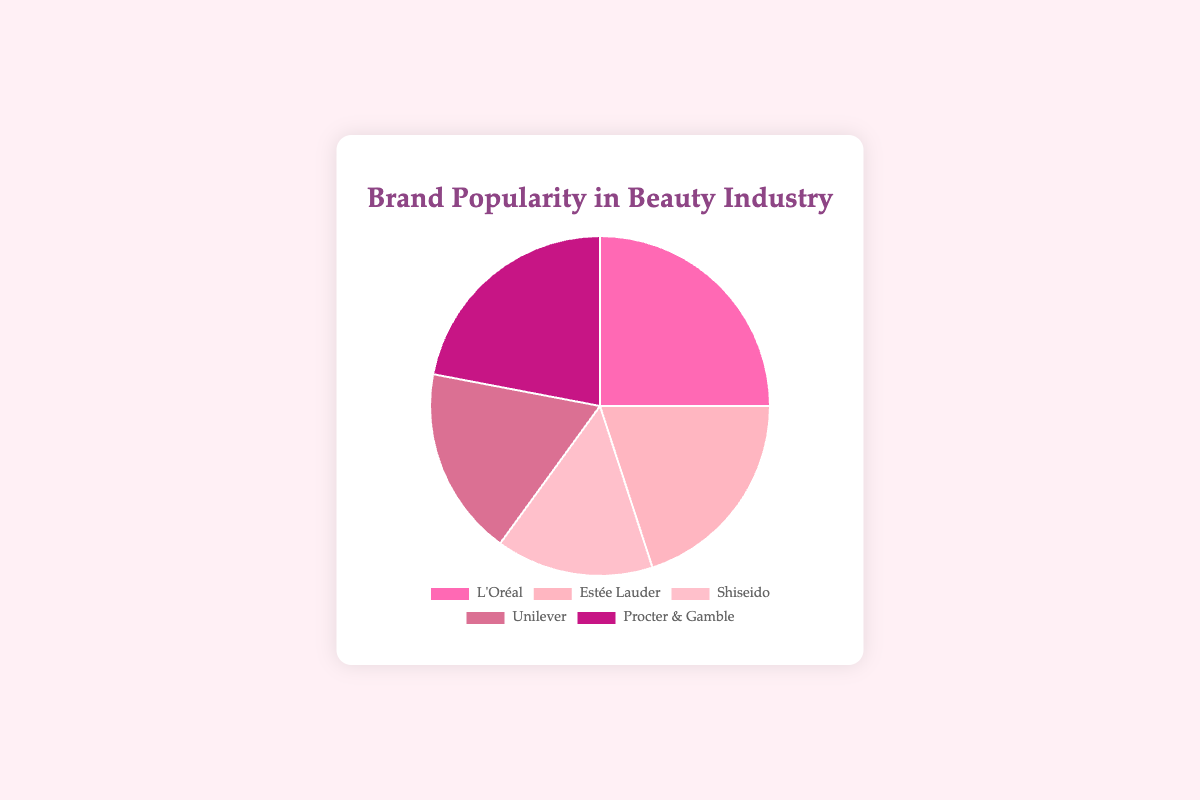What is the combined market share of L'Oréal and Estée Lauder? To find this, add the market share percentages of L'Oréal and Estée Lauder: 25% + 20% = 45%.
Answer: 45% Which brand has the highest market share? Look at the percentages and identify the brand with the highest value. L'Oréal has the highest market share at 25%.
Answer: L'Oréal What percentage separates the market shares of L'Oréal and Shiseido? Subtract Shiseido's percentage from L'Oréal's percentage: 25% - 15% = 10%.
Answer: 10% What is the difference in market share between Procter & Gamble and Unilever? Subtract Unilever's percentage from Procter & Gamble's percentage: 22% - 18% = 4%.
Answer: 4% Which brand has the smallest market share? Identify the brand with the lowest percentage. Shiseido has the smallest market share at 15%.
Answer: Shiseido How does the market share of Procter & Gamble compare to that of Estée Lauder? Compare the percentages of Procter & Gamble and Estée Lauder: 22% (Procter & Gamble) is greater than 20% (Estée Lauder).
Answer: Procter & Gamble What is the average market share of all the brands? Add all the percentages and divide by the number of brands: (25% + 20% + 15% + 18% + 22%) / 5 = 20%.
Answer: 20% Which brand is represented by the darkest pink color? The brand with the darkest pink color is Procter & Gamble, corresponding to the 22% slice.
Answer: Procter & Gamble What is the total market share of the three least popular brands? Add the percentages of the three brands with the smallest market shares: Shiseido (15%), Unilever (18%), and Estée Lauder (20%). 15% + 18% + 20% = 53%.
Answer: 53% How does the market share of L'Oréal compare to the combined market share of Unilever and Shiseido? L'Oréal has 25%. Unilever and Shiseido combined have 18% + 15% = 33%. L'Oréal's market share (25%) is less than that of Unilever and Shiseido combined (33%).
Answer: Less 